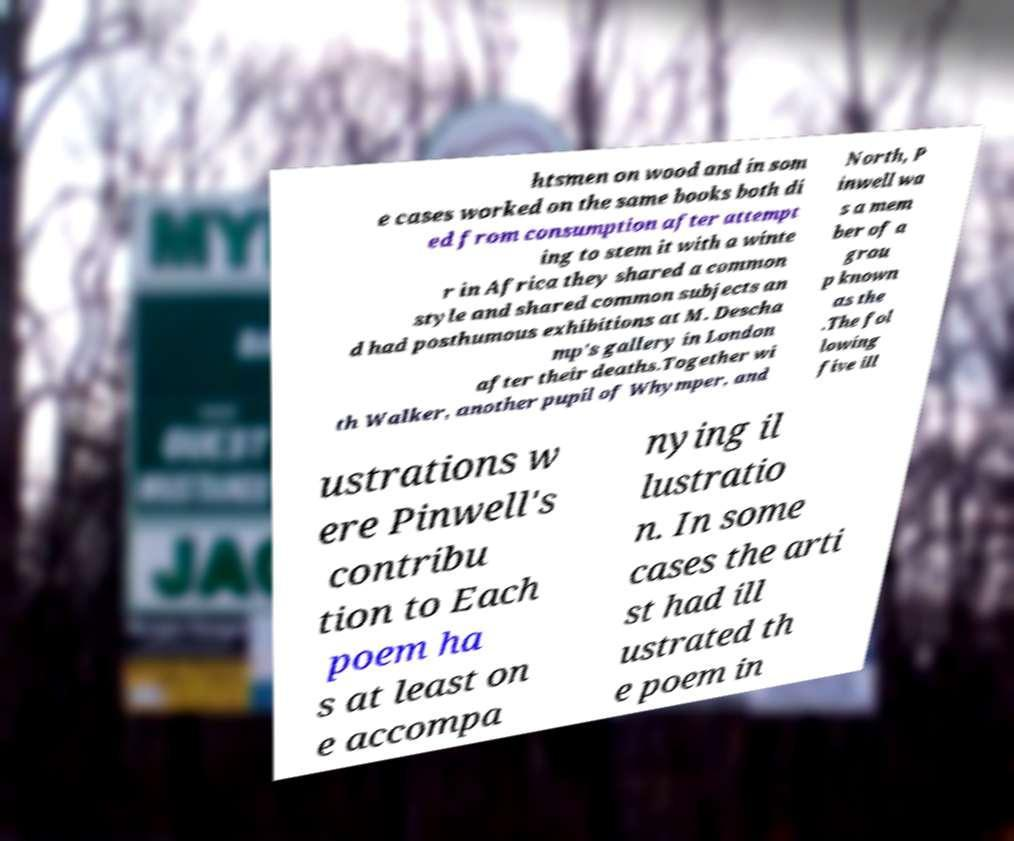Can you accurately transcribe the text from the provided image for me? htsmen on wood and in som e cases worked on the same books both di ed from consumption after attempt ing to stem it with a winte r in Africa they shared a common style and shared common subjects an d had posthumous exhibitions at M. Descha mp's gallery in London after their deaths.Together wi th Walker, another pupil of Whymper, and North, P inwell wa s a mem ber of a grou p known as the .The fol lowing five ill ustrations w ere Pinwell's contribu tion to Each poem ha s at least on e accompa nying il lustratio n. In some cases the arti st had ill ustrated th e poem in 